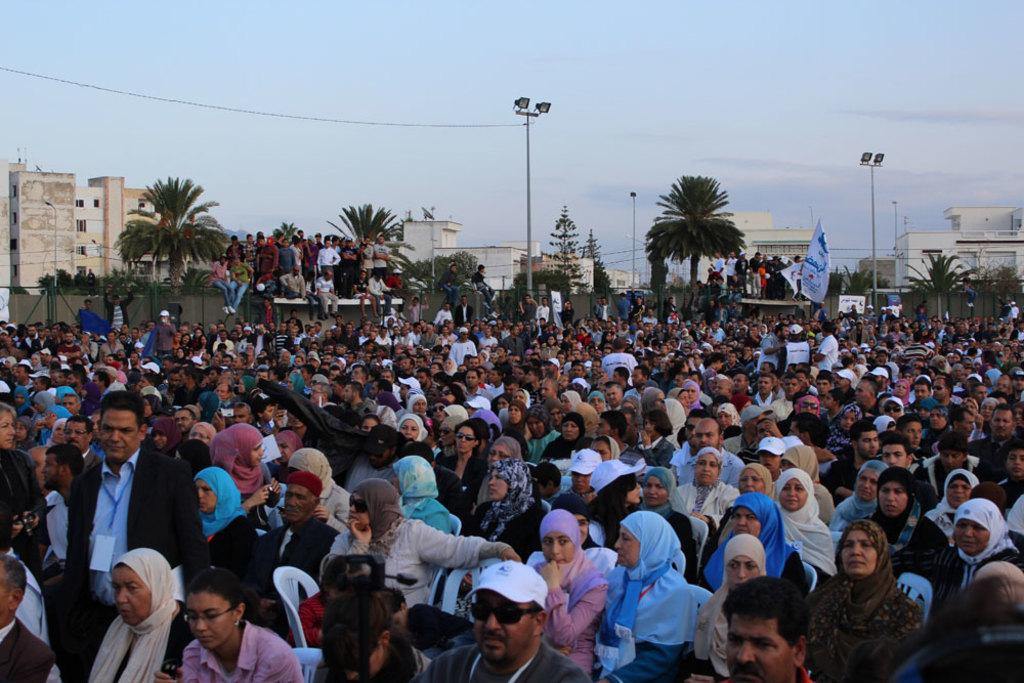How many people are in the group visible in the image? There is a group of people in the image, but the exact number cannot be determined from the provided facts. What can be seen in the background of the image? In the background of the image, there are buildings, trees, electric poles, banners, and the sky. What type of objects are present in the background of the image? There are objects in the background of the image, but their specific nature cannot be determined from the provided facts. What are the hobbies of the rays swimming in the image? There are no rays present in the image; it features a group of people and various elements in the background. 